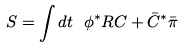Convert formula to latex. <formula><loc_0><loc_0><loc_500><loc_500>S = \int d t \ \phi ^ { * } R C + \bar { C } ^ { * } \bar { \pi }</formula> 